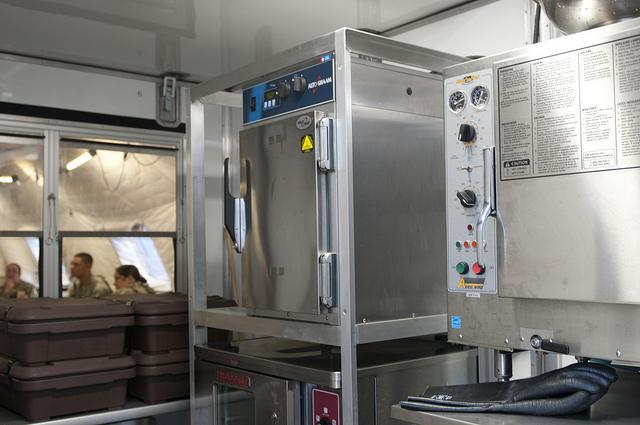What is the primary occupation of the diners?
Quick response, please. Military. Are these refrigerators in a home kitchen?
Short answer required. No. Is this a restaurant kitchen?
Be succinct. Yes. What is this room?
Write a very short answer. Kitchen. 